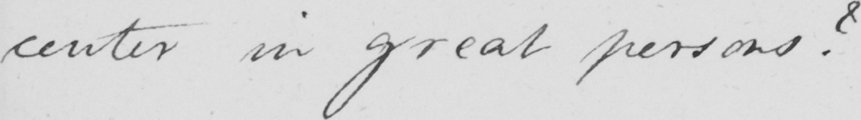What does this handwritten line say? center in great persons? 